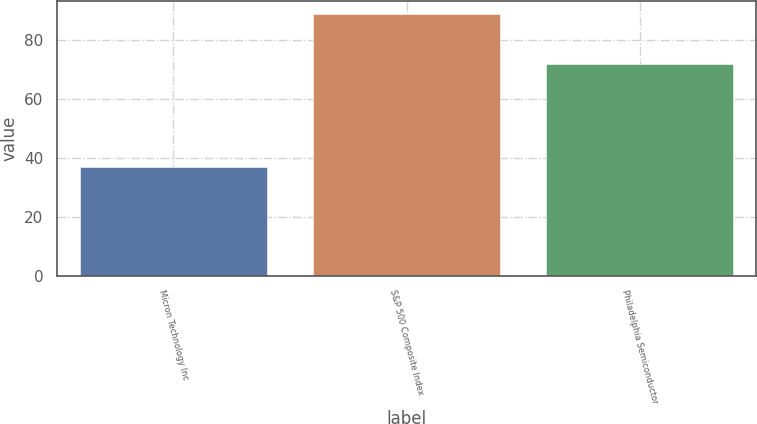Convert chart. <chart><loc_0><loc_0><loc_500><loc_500><bar_chart><fcel>Micron Technology Inc<fcel>S&P 500 Composite Index<fcel>Philadelphia Semiconductor<nl><fcel>37<fcel>89<fcel>72<nl></chart> 